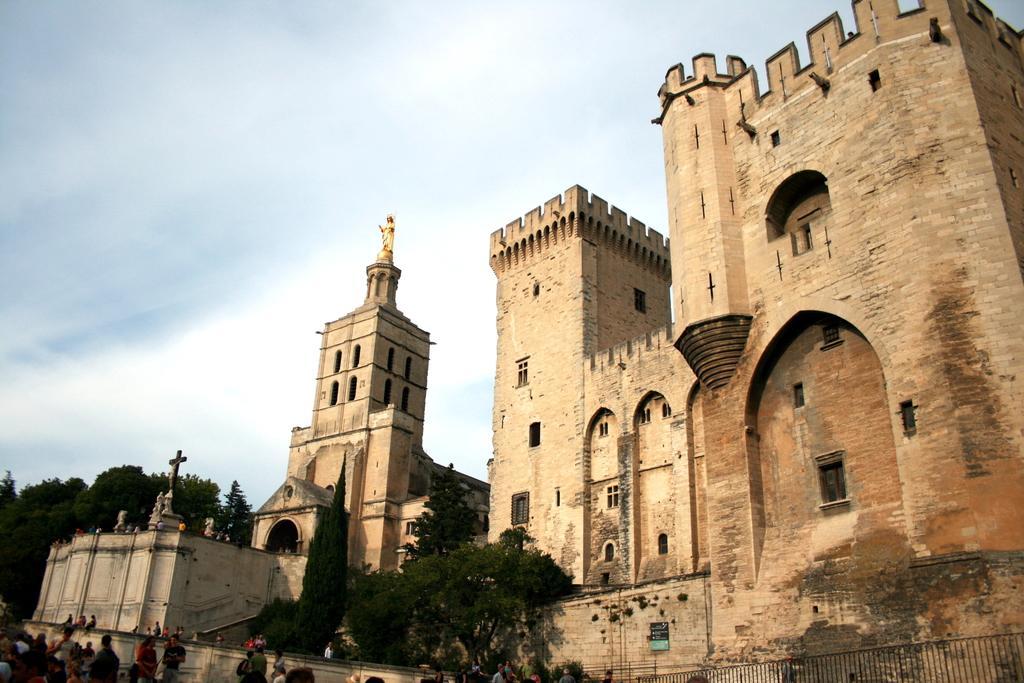Could you give a brief overview of what you see in this image? To the bottom left corner of the image there are few people. And to the right bottom corner of the image there is fencing. Behind them there are buildings with walls, arches and windows. To the left side of the image there is a building with statue on top of it. Behind the building there are trees. To the top of the image there is a blue sky 